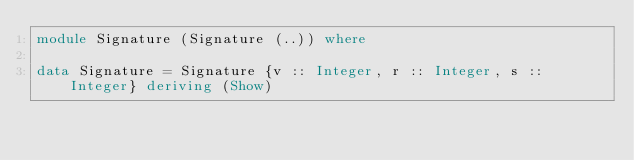Convert code to text. <code><loc_0><loc_0><loc_500><loc_500><_Haskell_>module Signature (Signature (..)) where

data Signature = Signature {v :: Integer, r :: Integer, s :: Integer} deriving (Show)
</code> 